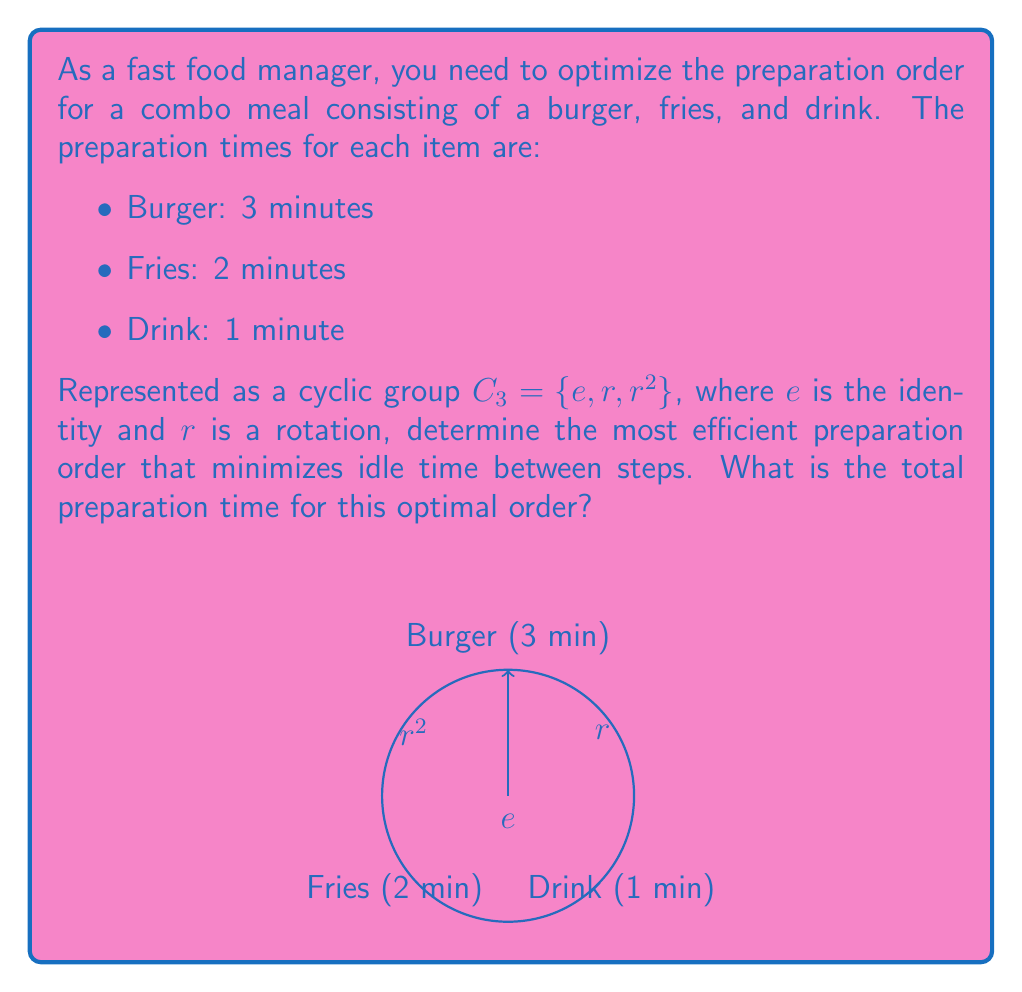Show me your answer to this math problem. To solve this problem, we'll use the properties of cyclic groups and consider the preparation times:

1) First, we need to understand that the cyclic group $C_3$ represents the three possible rotations of our preparation order.

2) The goal is to minimize idle time, which occurs when a shorter task finishes before a longer task.

3) Let's consider the possible orders:
   - $e$: Burger (3) → Fries (2) → Drink (1)
   - $r$: Fries (2) → Drink (1) → Burger (3)
   - $r^2$: Drink (1) → Burger (3) → Fries (2)

4) The most efficient order will be the one where each item finishes just as the next one needs to start.

5) The optimal order is $r^2$: Drink → Burger → Fries
   - Start the drink (1 min)
   - Start the burger immediately after (3 min)
   - Start the fries 1 minute before the burger finishes (2 min)

6) This order allows for parallel preparation with no idle time:
   $$\text{Total time} = \max(1, 1+3, 1+3-1+2) = 4\text{ minutes}$$

7) The cyclic group structure helps us systematically consider all possible rotations of the preparation order.
Answer: 4 minutes 